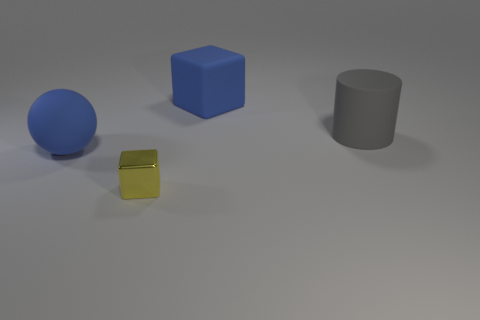Are there any other things that are the same size as the yellow metal object?
Your answer should be very brief. No. What shape is the large thing that is on the right side of the big matte cube?
Keep it short and to the point. Cylinder. There is a big blue object that is behind the large blue rubber thing that is in front of the cylinder; how many large rubber objects are left of it?
Make the answer very short. 1. Does the gray rubber thing have the same size as the cube to the left of the large cube?
Offer a very short reply. No. How big is the yellow thing on the right side of the big rubber object on the left side of the tiny yellow metallic block?
Your answer should be compact. Small. What number of other small blocks have the same material as the small cube?
Provide a succinct answer. 0. Are there any big cyan things?
Keep it short and to the point. No. There is a matte object on the left side of the rubber block; what is its size?
Make the answer very short. Large. What number of things are the same color as the big matte sphere?
Provide a succinct answer. 1. What number of cubes are red objects or gray rubber things?
Your answer should be very brief. 0. 